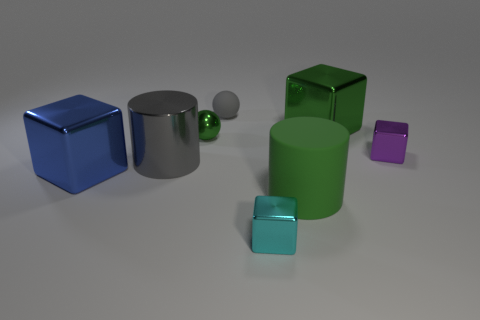Subtract all green cubes. How many cubes are left? 3 Add 2 purple cubes. How many objects exist? 10 Subtract all red blocks. Subtract all green cylinders. How many blocks are left? 4 Subtract all spheres. How many objects are left? 6 Add 4 large metal things. How many large metal things exist? 7 Subtract 0 purple cylinders. How many objects are left? 8 Subtract all large green things. Subtract all gray matte spheres. How many objects are left? 5 Add 1 gray balls. How many gray balls are left? 2 